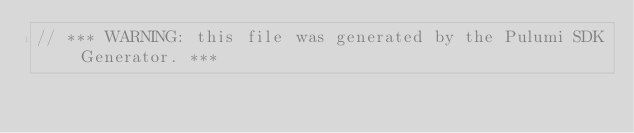Convert code to text. <code><loc_0><loc_0><loc_500><loc_500><_C#_>// *** WARNING: this file was generated by the Pulumi SDK Generator. ***</code> 